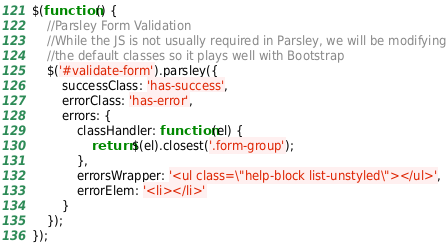<code> <loc_0><loc_0><loc_500><loc_500><_JavaScript_>$(function () {
    //Parsley Form Validation
    //While the JS is not usually required in Parsley, we will be modifying
    //the default classes so it plays well with Bootstrap
    $('#validate-form').parsley({
        successClass: 'has-success',
        errorClass: 'has-error',
        errors: {
            classHandler: function (el) {
                return $(el).closest('.form-group');
            },
            errorsWrapper: '<ul class=\"help-block list-unstyled\"></ul>',
            errorElem: '<li></li>'
        }
    });
});</code> 